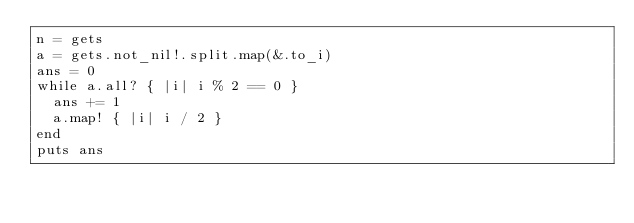Convert code to text. <code><loc_0><loc_0><loc_500><loc_500><_Crystal_>n = gets
a = gets.not_nil!.split.map(&.to_i)
ans = 0
while a.all? { |i| i % 2 == 0 }
  ans += 1
  a.map! { |i| i / 2 }
end
puts ans
</code> 